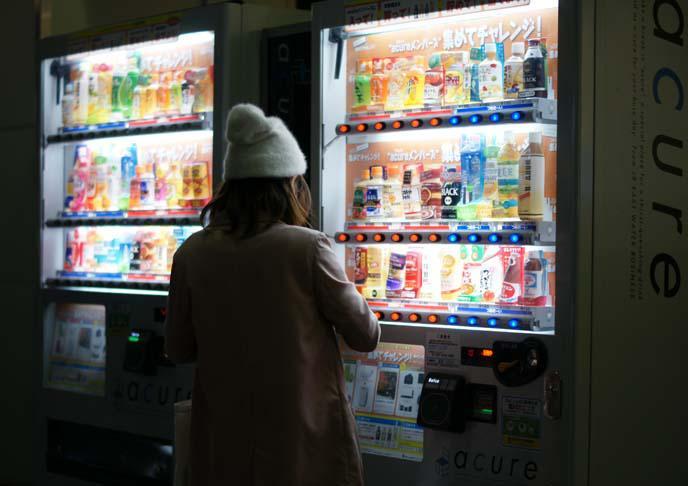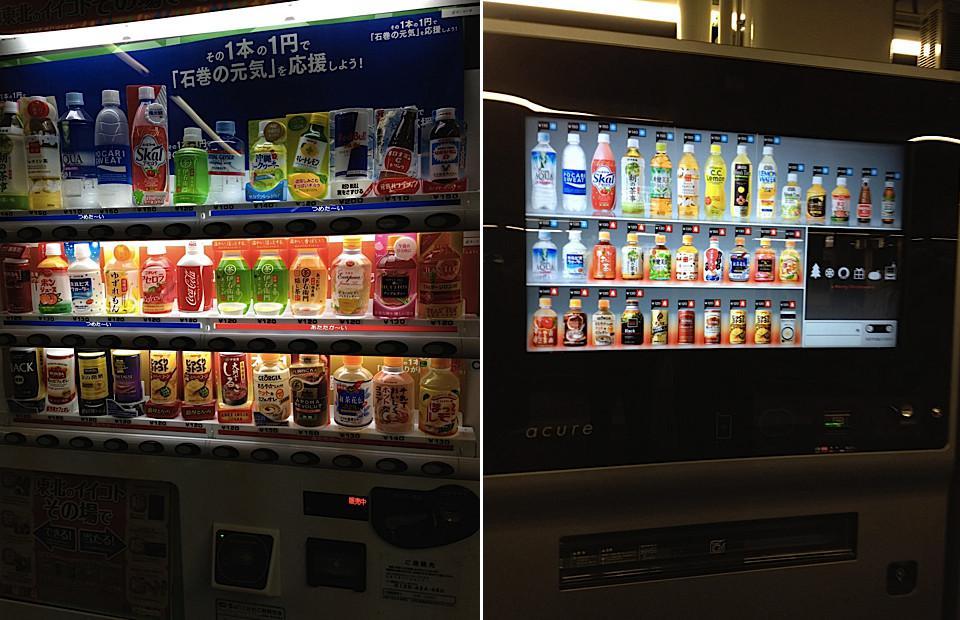The first image is the image on the left, the second image is the image on the right. Examine the images to the left and right. Is the description "None of the images show more than two vending machines." accurate? Answer yes or no. Yes. The first image is the image on the left, the second image is the image on the right. Assess this claim about the two images: "There are no more than two vending machines in the image on the right.". Correct or not? Answer yes or no. Yes. 